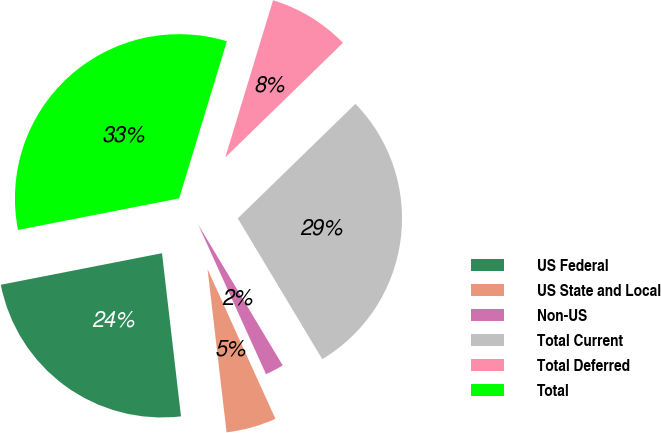<chart> <loc_0><loc_0><loc_500><loc_500><pie_chart><fcel>US Federal<fcel>US State and Local<fcel>Non-US<fcel>Total Current<fcel>Total Deferred<fcel>Total<nl><fcel>23.77%<fcel>4.93%<fcel>1.83%<fcel>28.68%<fcel>8.02%<fcel>32.77%<nl></chart> 